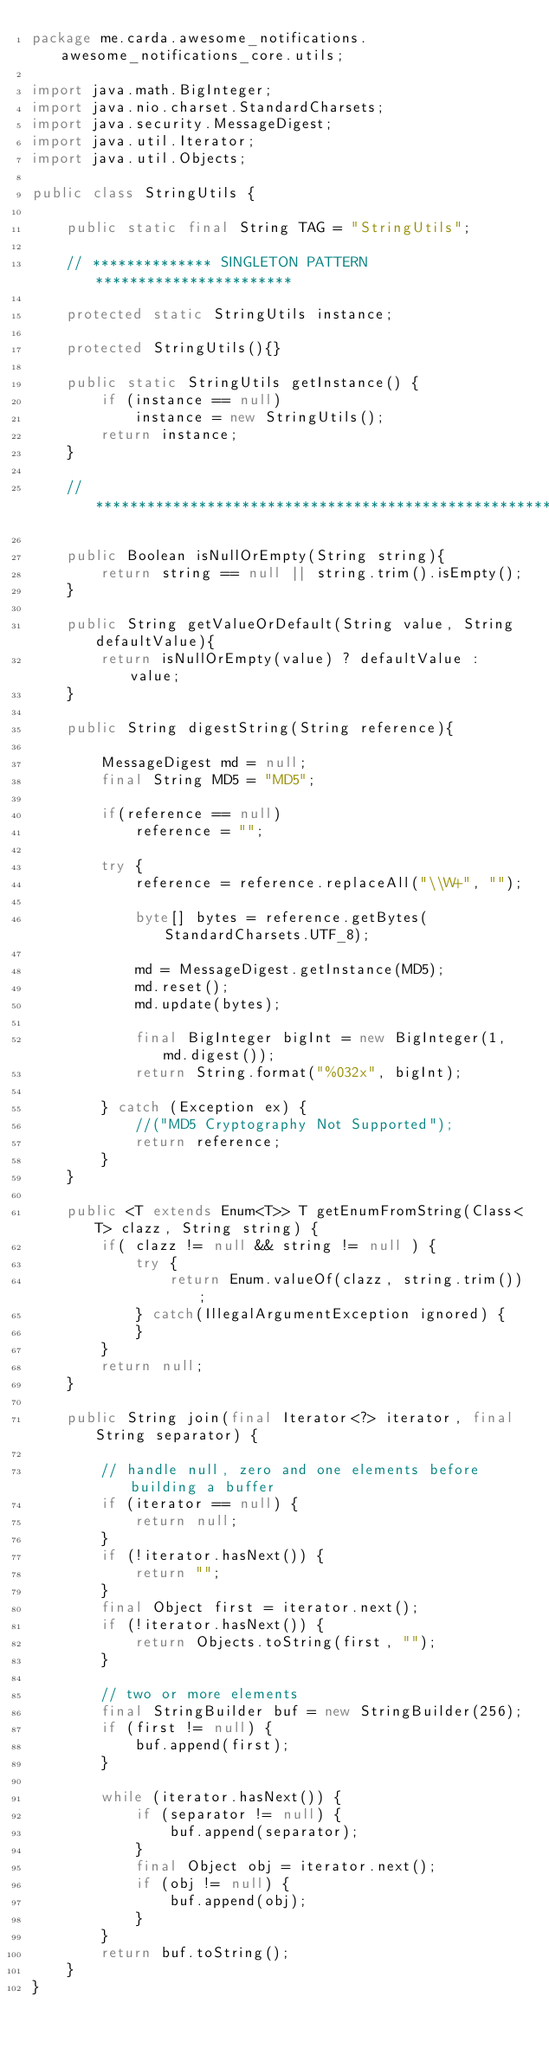Convert code to text. <code><loc_0><loc_0><loc_500><loc_500><_Java_>package me.carda.awesome_notifications.awesome_notifications_core.utils;

import java.math.BigInteger;
import java.nio.charset.StandardCharsets;
import java.security.MessageDigest;
import java.util.Iterator;
import java.util.Objects;

public class StringUtils {

    public static final String TAG = "StringUtils";

    // ************** SINGLETON PATTERN ***********************

    protected static StringUtils instance;

    protected StringUtils(){}

    public static StringUtils getInstance() {
        if (instance == null)
            instance = new StringUtils();
        return instance;
    }

    // ********************************************************

    public Boolean isNullOrEmpty(String string){
        return string == null || string.trim().isEmpty();
    }

    public String getValueOrDefault(String value, String defaultValue){
        return isNullOrEmpty(value) ? defaultValue : value;
    }

    public String digestString(String reference){

        MessageDigest md = null;
        final String MD5 = "MD5";

        if(reference == null)
            reference = "";

        try {
            reference = reference.replaceAll("\\W+", "");

            byte[] bytes = reference.getBytes(StandardCharsets.UTF_8);

            md = MessageDigest.getInstance(MD5);
            md.reset();
            md.update(bytes);

            final BigInteger bigInt = new BigInteger(1, md.digest());
            return String.format("%032x", bigInt);

        } catch (Exception ex) {
            //("MD5 Cryptography Not Supported");
            return reference;
        }
    }

    public <T extends Enum<T>> T getEnumFromString(Class<T> clazz, String string) {
        if( clazz != null && string != null ) {
            try {
                return Enum.valueOf(clazz, string.trim());
            } catch(IllegalArgumentException ignored) {
            }
        }
        return null;
    }

    public String join(final Iterator<?> iterator, final String separator) {

        // handle null, zero and one elements before building a buffer
        if (iterator == null) {
            return null;
        }
        if (!iterator.hasNext()) {
            return "";
        }
        final Object first = iterator.next();
        if (!iterator.hasNext()) {
            return Objects.toString(first, "");
        }

        // two or more elements
        final StringBuilder buf = new StringBuilder(256);
        if (first != null) {
            buf.append(first);
        }

        while (iterator.hasNext()) {
            if (separator != null) {
                buf.append(separator);
            }
            final Object obj = iterator.next();
            if (obj != null) {
                buf.append(obj);
            }
        }
        return buf.toString();
    }
}
</code> 